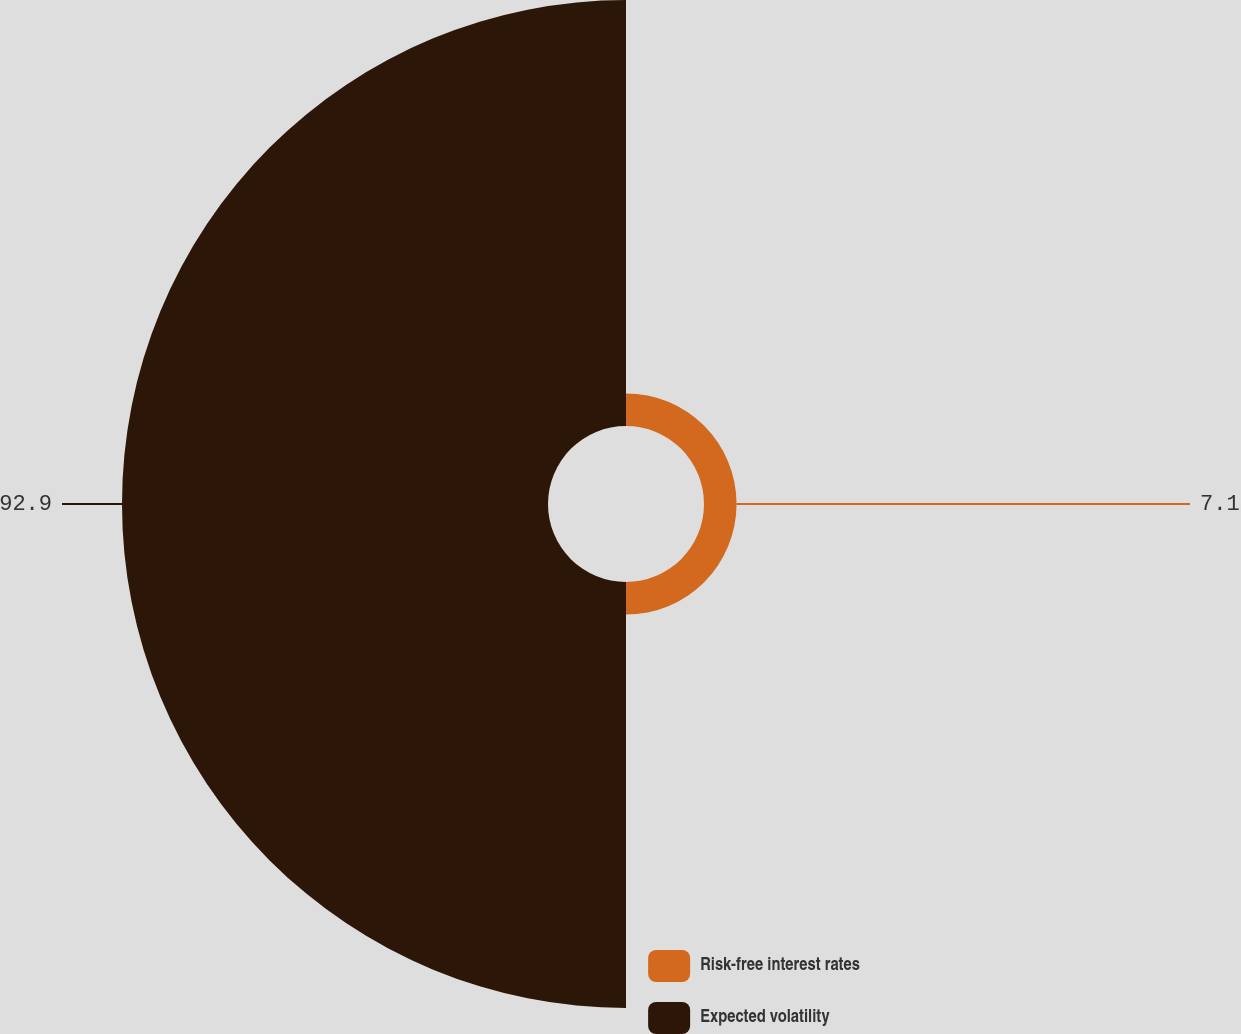<chart> <loc_0><loc_0><loc_500><loc_500><pie_chart><fcel>Risk-free interest rates<fcel>Expected volatility<nl><fcel>7.1%<fcel>92.9%<nl></chart> 